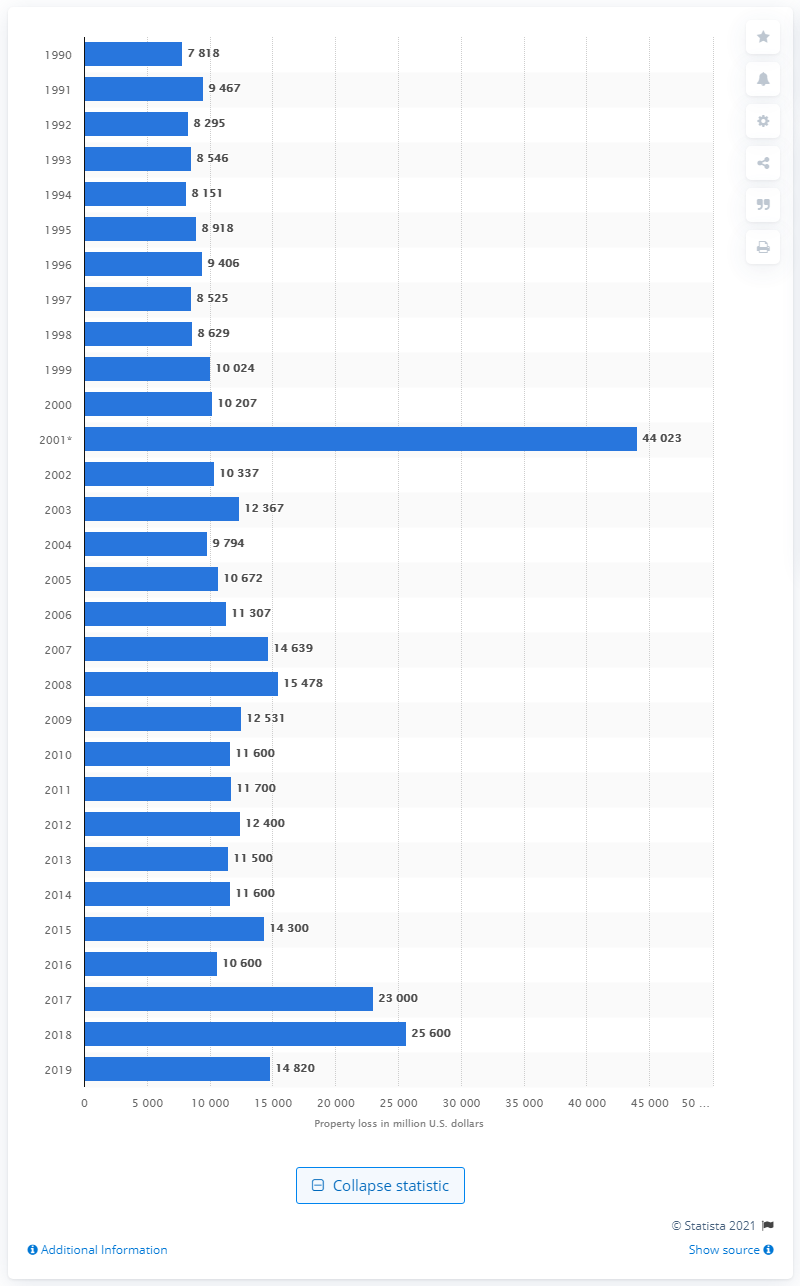Mention a couple of crucial points in this snapshot. According to data from 2019, the United States experienced significant property losses due to fires. According to estimates, fires resulted in approximately 25,600 instances of property loss in 2018. 